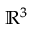Convert formula to latex. <formula><loc_0><loc_0><loc_500><loc_500>{ \mathbb { R } } ^ { 3 }</formula> 